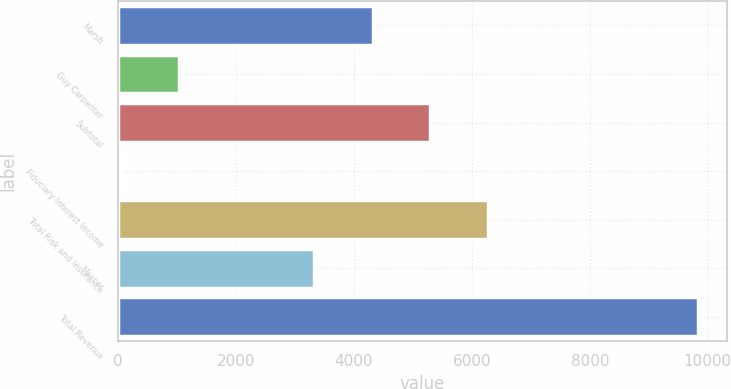Convert chart. <chart><loc_0><loc_0><loc_500><loc_500><bar_chart><fcel>Marsh<fcel>Guy Carpenter<fcel>Subtotal<fcel>Fiduciary Interest Income<fcel>Total Risk and Insurance<fcel>Mercer<fcel>Total Revenue<nl><fcel>4319<fcel>1031.7<fcel>5296.7<fcel>54<fcel>6274.4<fcel>3327<fcel>9831<nl></chart> 